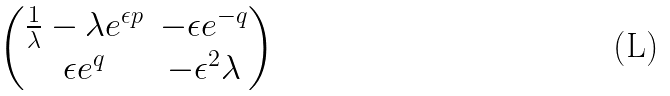Convert formula to latex. <formula><loc_0><loc_0><loc_500><loc_500>\begin{pmatrix} \frac { 1 } { \lambda } - \lambda e ^ { \epsilon p } & - \epsilon e ^ { - q } \\ \epsilon e ^ { q } & - \epsilon ^ { 2 } \lambda \end{pmatrix}</formula> 